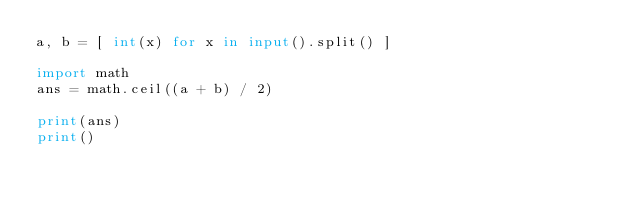<code> <loc_0><loc_0><loc_500><loc_500><_Python_>a, b = [ int(x) for x in input().split() ]

import math
ans = math.ceil((a + b) / 2)

print(ans)
print()
</code> 